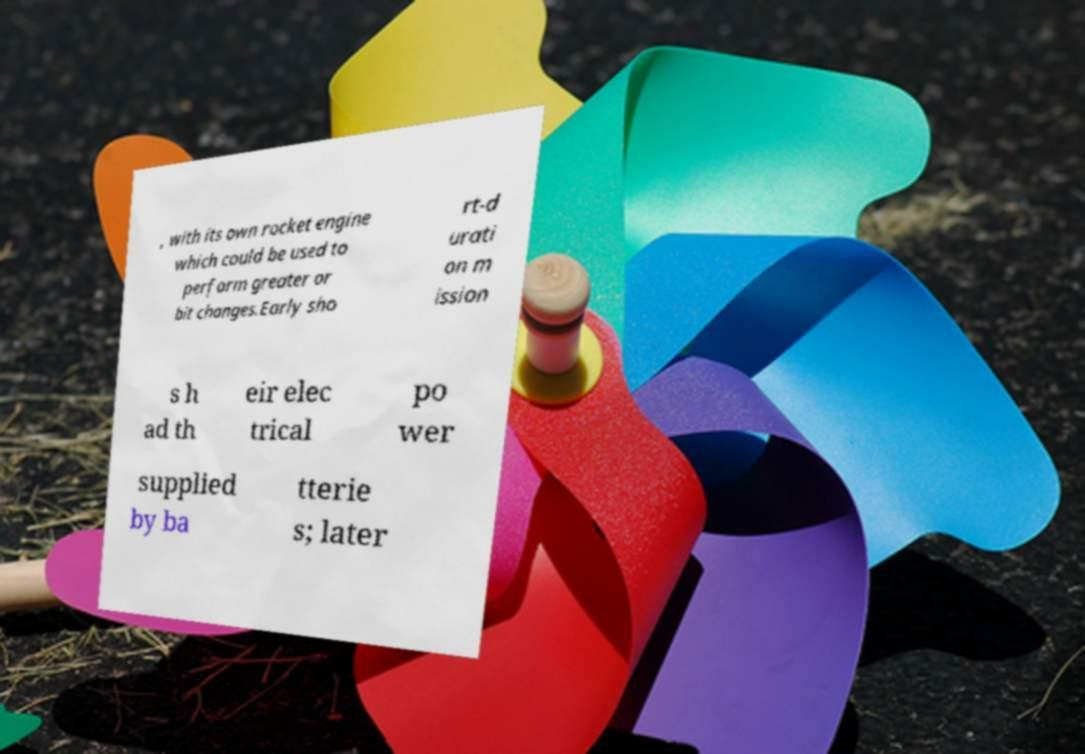For documentation purposes, I need the text within this image transcribed. Could you provide that? , with its own rocket engine which could be used to perform greater or bit changes.Early sho rt-d urati on m ission s h ad th eir elec trical po wer supplied by ba tterie s; later 